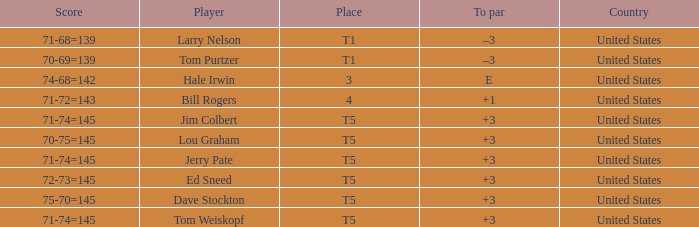What country is player ed sneed, who has a to par of +3, from? United States. 